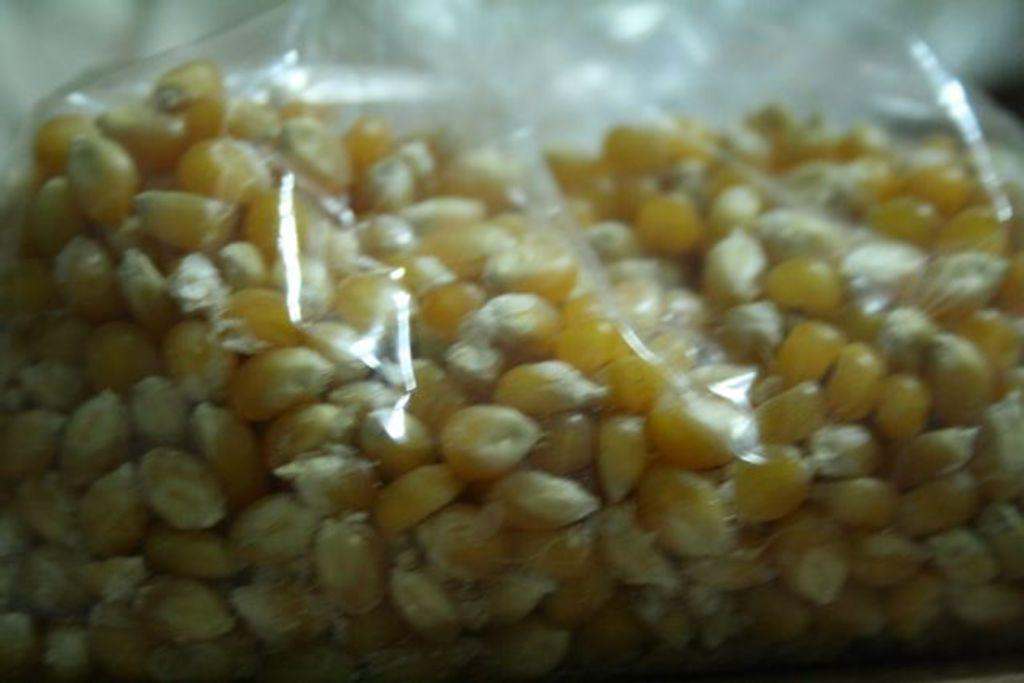What type of food is in the packet that is visible in the image? There is corn in a packet in the image. Are there any bears playing with balls in the position shown in the image? There are no bears or balls present in the image; it only features a packet of corn. 